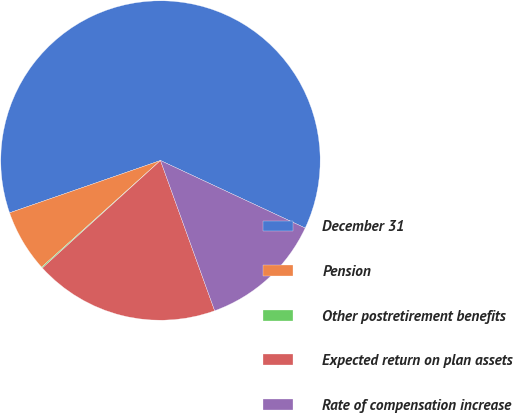<chart> <loc_0><loc_0><loc_500><loc_500><pie_chart><fcel>December 31<fcel>Pension<fcel>Other postretirement benefits<fcel>Expected return on plan assets<fcel>Rate of compensation increase<nl><fcel>62.26%<fcel>6.33%<fcel>0.11%<fcel>18.76%<fcel>12.54%<nl></chart> 